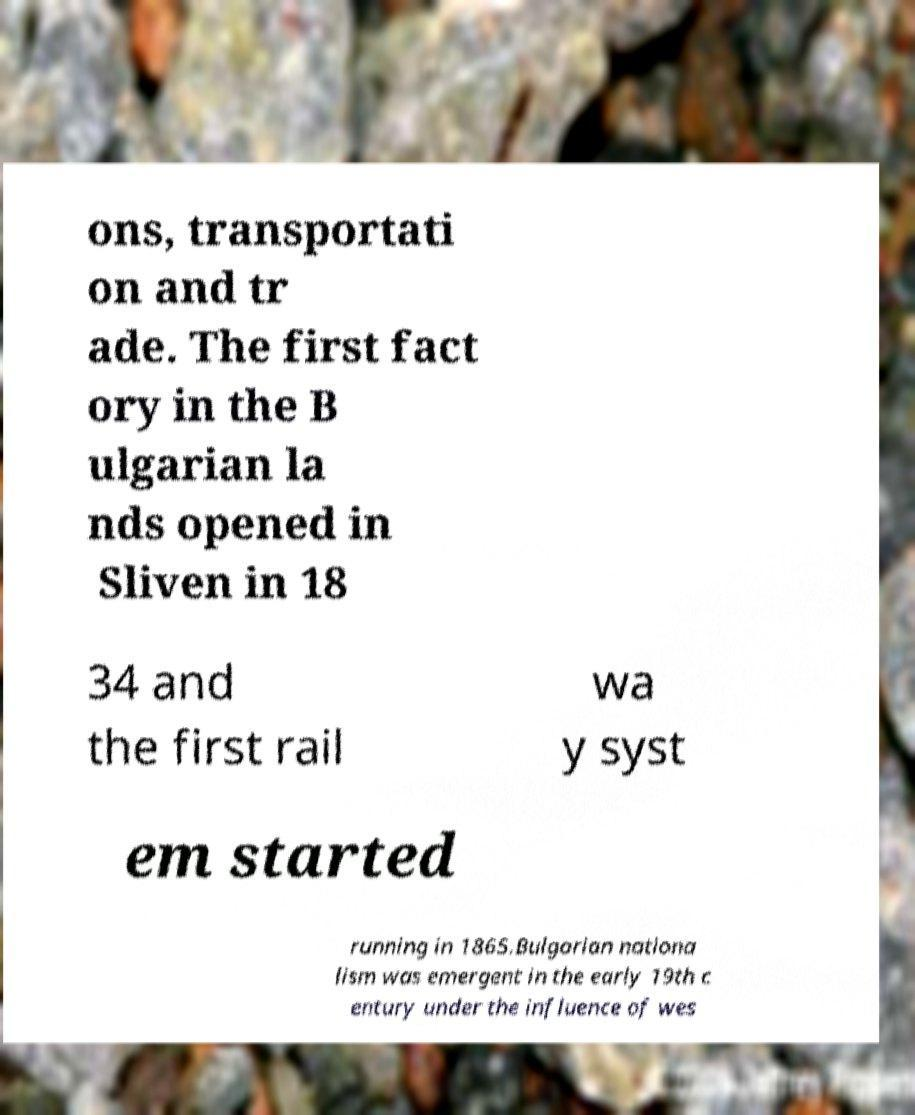Please identify and transcribe the text found in this image. ons, transportati on and tr ade. The first fact ory in the B ulgarian la nds opened in Sliven in 18 34 and the first rail wa y syst em started running in 1865.Bulgarian nationa lism was emergent in the early 19th c entury under the influence of wes 